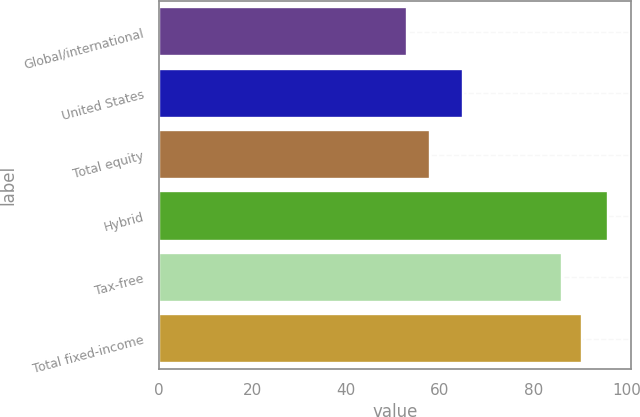Convert chart to OTSL. <chart><loc_0><loc_0><loc_500><loc_500><bar_chart><fcel>Global/international<fcel>United States<fcel>Total equity<fcel>Hybrid<fcel>Tax-free<fcel>Total fixed-income<nl><fcel>53<fcel>65<fcel>58<fcel>96<fcel>86<fcel>90.3<nl></chart> 